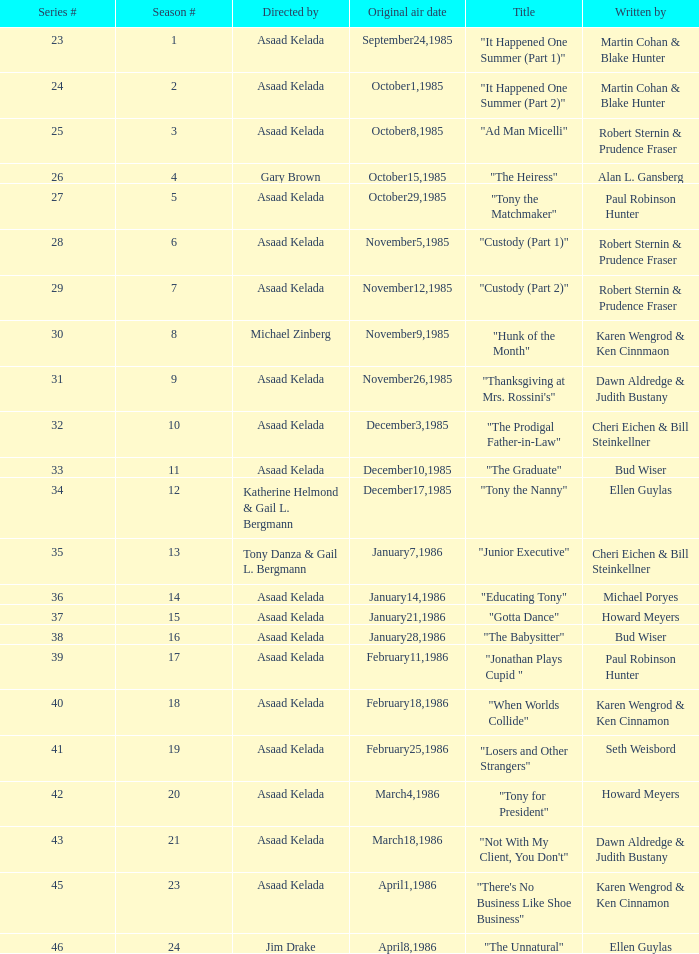What season features writer Michael Poryes? 14.0. 